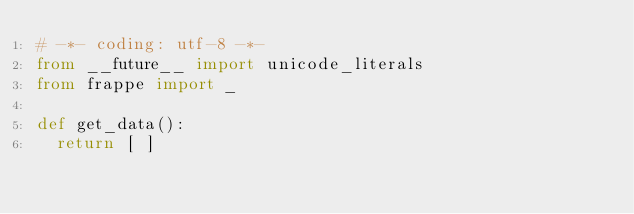Convert code to text. <code><loc_0><loc_0><loc_500><loc_500><_Python_># -*- coding: utf-8 -*-
from __future__ import unicode_literals
from frappe import _

def get_data():
	return [ ]
</code> 